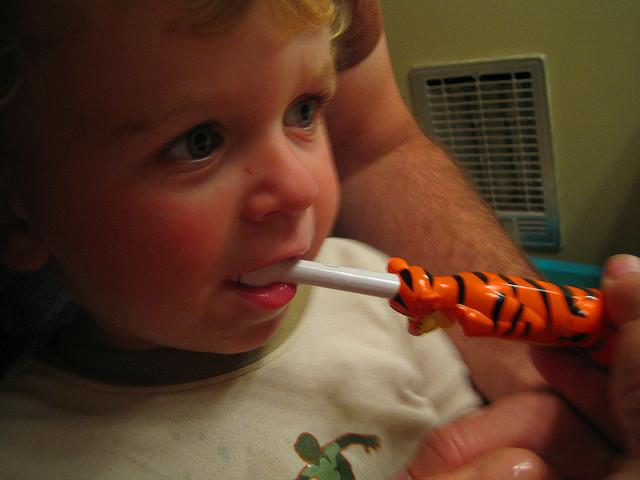What is on the end of tigger's head? toothbrush 